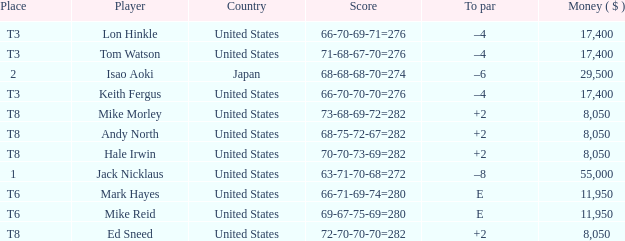What to par is located in the united states and has the player by the name of hale irwin? 2.0. 